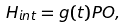<formula> <loc_0><loc_0><loc_500><loc_500>H _ { i n t } = g ( t ) P O ,</formula> 